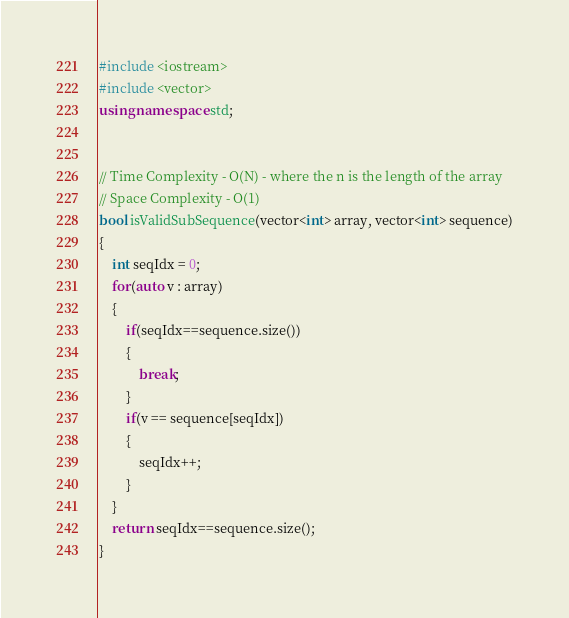<code> <loc_0><loc_0><loc_500><loc_500><_C++_>#include <iostream>
#include <vector>
using namespace std;


// Time Complexity - O(N) - where the n is the length of the array
// Space Complexity - O(1)
bool isValidSubSequence(vector<int> array, vector<int> sequence)
{
	int seqIdx = 0;
	for(auto v : array)
	{
		if(seqIdx==sequence.size())
		{
			break;
		}
		if(v == sequence[seqIdx])
		{
			seqIdx++;
		}
	}
	return seqIdx==sequence.size();
}</code> 